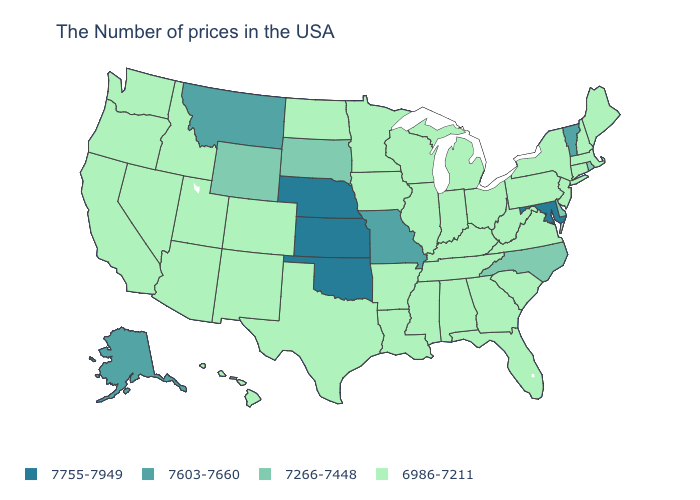Is the legend a continuous bar?
Concise answer only. No. Does the first symbol in the legend represent the smallest category?
Write a very short answer. No. Among the states that border Kentucky , does Missouri have the highest value?
Write a very short answer. Yes. Does the first symbol in the legend represent the smallest category?
Be succinct. No. Name the states that have a value in the range 7755-7949?
Quick response, please. Maryland, Kansas, Nebraska, Oklahoma. Name the states that have a value in the range 6986-7211?
Give a very brief answer. Maine, Massachusetts, New Hampshire, Connecticut, New York, New Jersey, Pennsylvania, Virginia, South Carolina, West Virginia, Ohio, Florida, Georgia, Michigan, Kentucky, Indiana, Alabama, Tennessee, Wisconsin, Illinois, Mississippi, Louisiana, Arkansas, Minnesota, Iowa, Texas, North Dakota, Colorado, New Mexico, Utah, Arizona, Idaho, Nevada, California, Washington, Oregon, Hawaii. Does Georgia have the lowest value in the South?
Be succinct. Yes. Name the states that have a value in the range 7603-7660?
Answer briefly. Vermont, Missouri, Montana, Alaska. What is the value of Massachusetts?
Keep it brief. 6986-7211. Name the states that have a value in the range 7266-7448?
Quick response, please. Rhode Island, Delaware, North Carolina, South Dakota, Wyoming. Name the states that have a value in the range 7266-7448?
Keep it brief. Rhode Island, Delaware, North Carolina, South Dakota, Wyoming. What is the value of Virginia?
Quick response, please. 6986-7211. Does New Hampshire have the lowest value in the Northeast?
Concise answer only. Yes. 